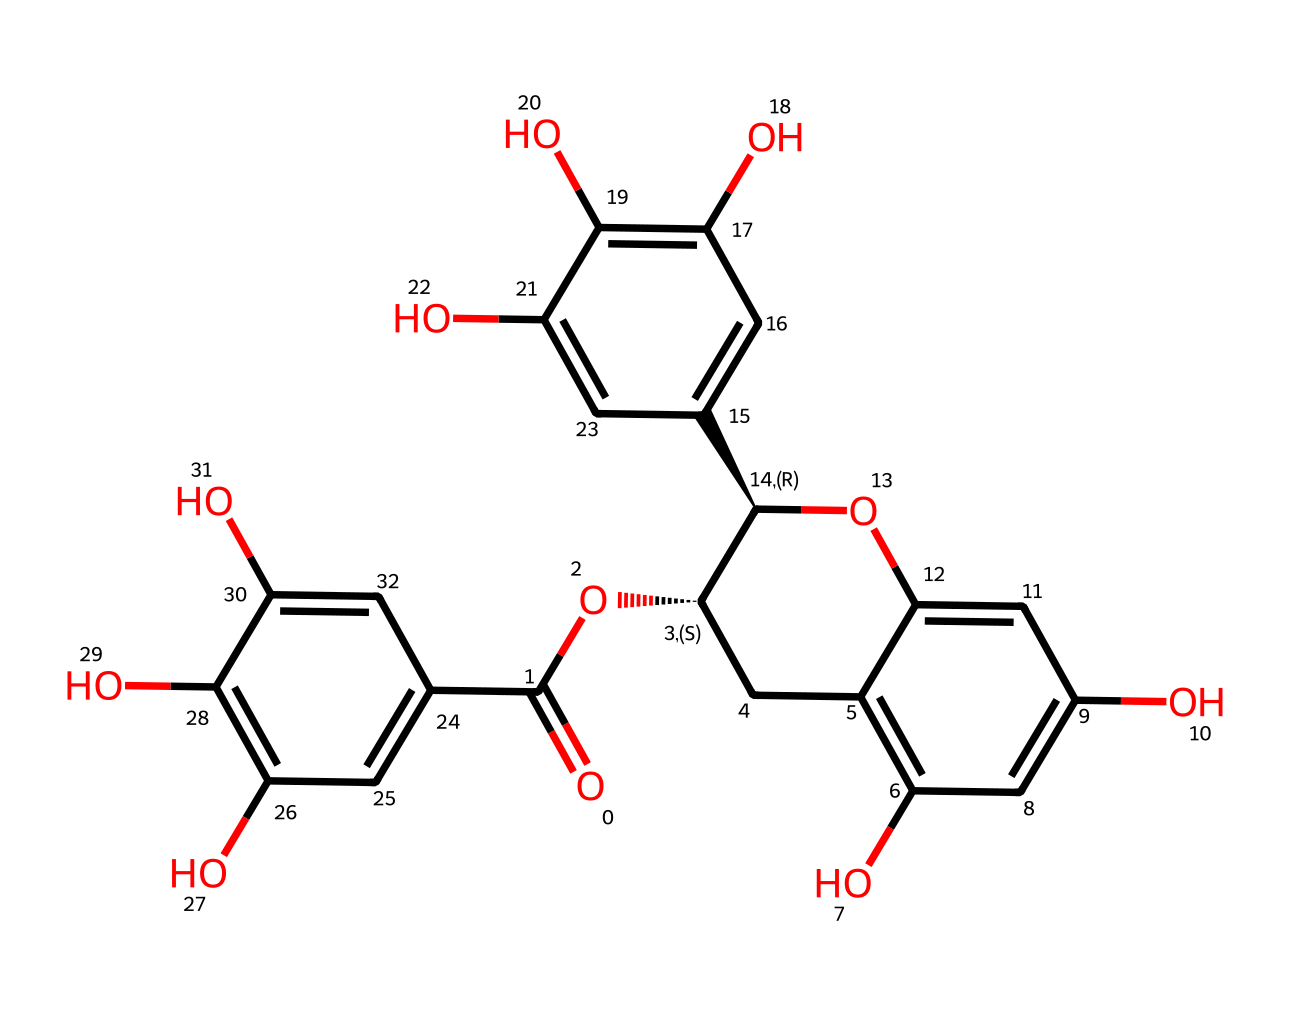What is the molecular formula of the compound represented by the SMILES? To determine the molecular formula, we need to count the number of each type of atom based on the structure. Analyzing the SMILES reveals a total of 21 carbons (C), 22 hydrogens (H), and 11 oxygens (O). Thus, the molecular formula is C21H22O11.
Answer: C21H22O11 How many hydroxyl (–OH) groups are present in the molecule? By examining the chemical structure, we can identify the locations of hydroxyl groups. Each –OH group corresponds to a functional group that has an oxygen bonded to a hydrogen, which is visible in the structure. The molecule contains five hydroxyl groups.
Answer: 5 What type of functional groups are primarily present in this molecular structure? The primary functional groups in this molecular structure are hydroxyl groups (alcohols) and ester groups, which are common in many antioxidants found in tea. Observing multiple –OH groups suggests phenolic characteristics typical of antioxidants.
Answer: hydroxyl and ester How many total rings are in the molecular structure? A careful look at the configuration of the atoms reveals the presence of interconnected rings. By visual inspection of the fused cyclic structures, it can be noted that there are three distinct rings in this chemical structure.
Answer: 3 Is this compound likely to be polar or nonpolar, and why? Analyzing the presence of hydroxyl groups, which increase polarity, and the arrangement of the carbon backbone, we conclude that the compound is overall polar due to the numerous –OH groups present. The presence of these polar functional groups allows for hydrogen bonding, increasing solubility in water.
Answer: polar 